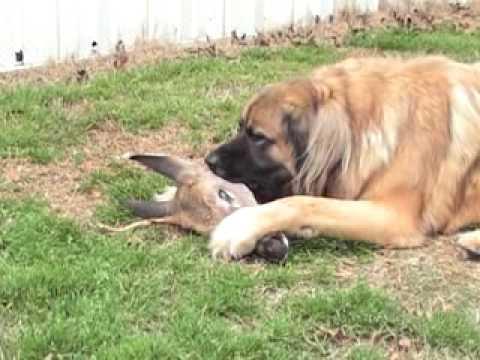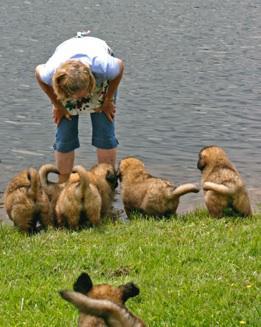The first image is the image on the left, the second image is the image on the right. For the images shown, is this caption "The left image shows a reclining big-breed adult dog chewing on some type of raw meat, and the right image shows at least one big-breed puppy." true? Answer yes or no. Yes. The first image is the image on the left, the second image is the image on the right. Evaluate the accuracy of this statement regarding the images: "There is an adult dog chewing on the animal flesh.". Is it true? Answer yes or no. Yes. 